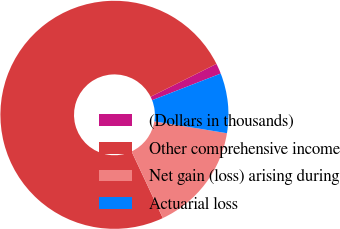<chart> <loc_0><loc_0><loc_500><loc_500><pie_chart><fcel>(Dollars in thousands)<fcel>Other comprehensive income<fcel>Net gain (loss) arising during<fcel>Actuarial loss<nl><fcel>1.48%<fcel>74.6%<fcel>15.45%<fcel>8.47%<nl></chart> 